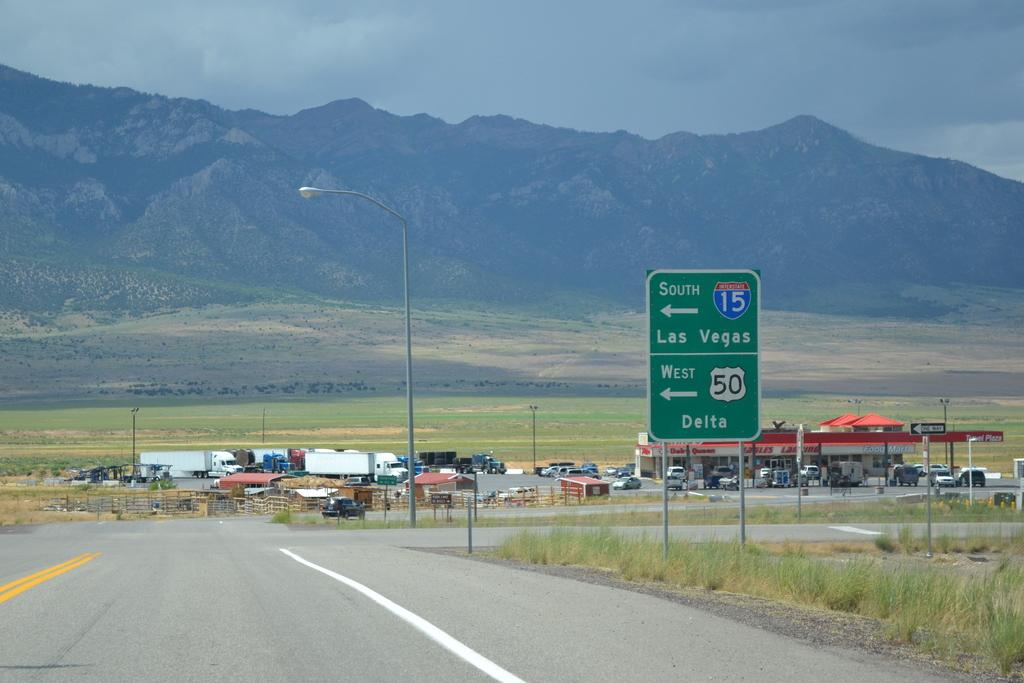<image>
Describe the image concisely. A highway sign directing to Las Vegas in front of mountains on a cloudy day. 